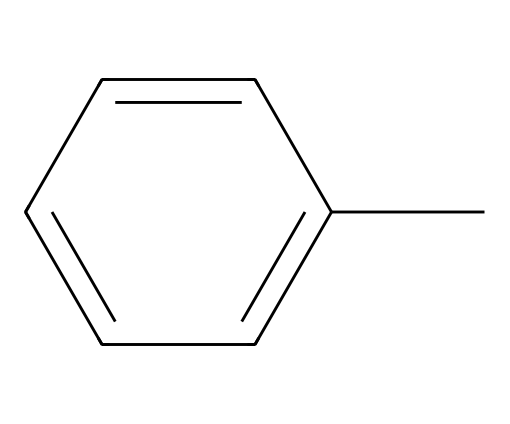What is the molecular formula of this chemical? The SMILES representation shows a toluene molecule, which consists of a benzene ring with a methyl group attached. The benzene ring has six carbon atoms, and the methyl group contributes one more carbon and three hydrogen atoms, making the total molecular formula C7H8.
Answer: C7H8 How many carbon atoms are in this compound? The SMILES representation indicates that there are seven carbon atoms: six in the benzene ring and one in the methyl group. Therefore, by counting, we find a total of seven carbon atoms.
Answer: 7 What type of bond is primarily responsible for maintaining the structure of this aromatic compound? The structure of toluene includes alternating single and double bonds between the carbon atoms in the benzene ring, which is characteristic of aromatic compounds. The stability of the benzene structure is mainly attributed to resonance, where the electrons are delocalized across the ring.
Answer: resonance Does this chemical have a pungent smell? Toluene is well-known for its strong and sweet odor, which can be described as pungent. The presence of the methyl group contributes to its volatile nature, allowing it to easily evaporate and release its characteristic smell.
Answer: yes What functional group can be identified in this structure? The structure of toluene contains a methyl group (–CH3) attached to the benzene ring. This group is a primary functional group in toluene, designating it as an aromatic hydrocarbon with one substituent.
Answer: methyl group Is toluene polar or nonpolar? Toluene is primarily considered nonpolar due to its aromatic hydrocarbon structure, as the carbon and hydrogen atoms share electrons equally. The nonpolar characteristic mainly arises from the symmetry of the molecule and the nature of the bonds involved.
Answer: nonpolar 